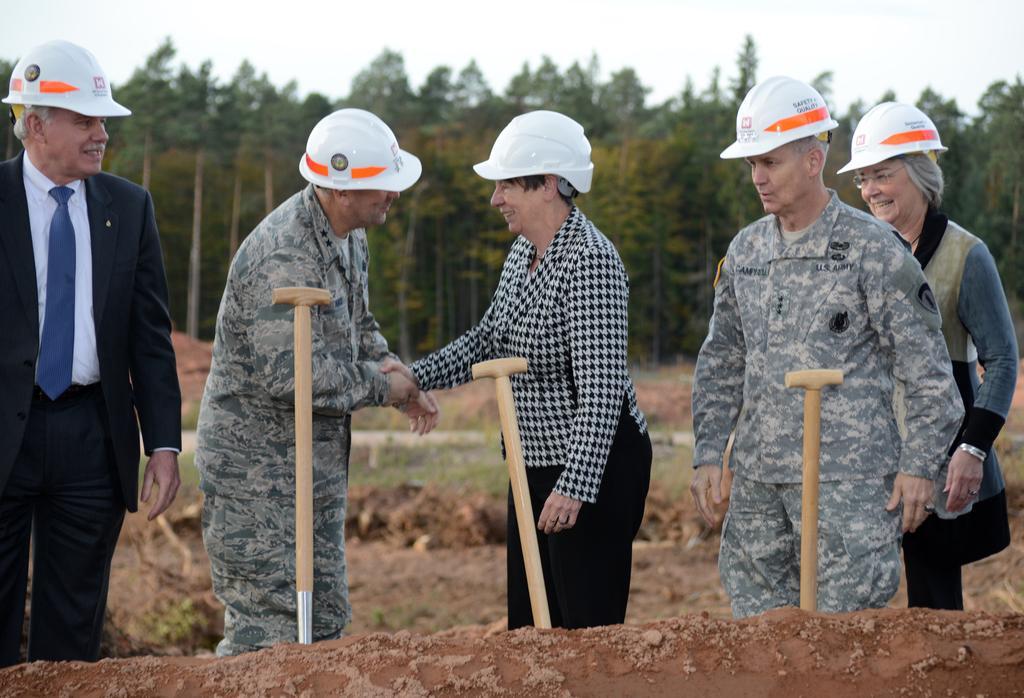Can you describe this image briefly? There is a group of persons standing and wearing a white color helmets as we can see in the middle of this image. There are some trees in the background, and there is a sky at the top of this image. 